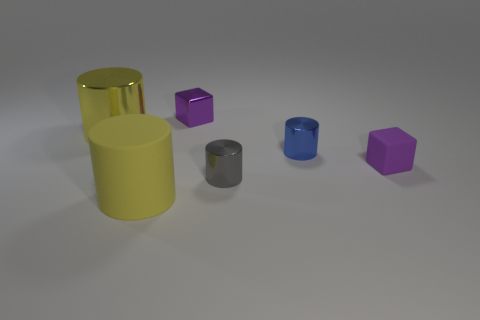Subtract all cyan blocks. How many yellow cylinders are left? 2 Subtract all large matte cylinders. How many cylinders are left? 3 Add 4 purple things. How many objects exist? 10 Subtract all gray cylinders. How many cylinders are left? 3 Subtract all cylinders. How many objects are left? 2 Add 5 yellow metal cylinders. How many yellow metal cylinders exist? 6 Subtract 0 purple cylinders. How many objects are left? 6 Subtract all blue cylinders. Subtract all blue spheres. How many cylinders are left? 3 Subtract all small objects. Subtract all large purple shiny balls. How many objects are left? 2 Add 5 tiny blue cylinders. How many tiny blue cylinders are left? 6 